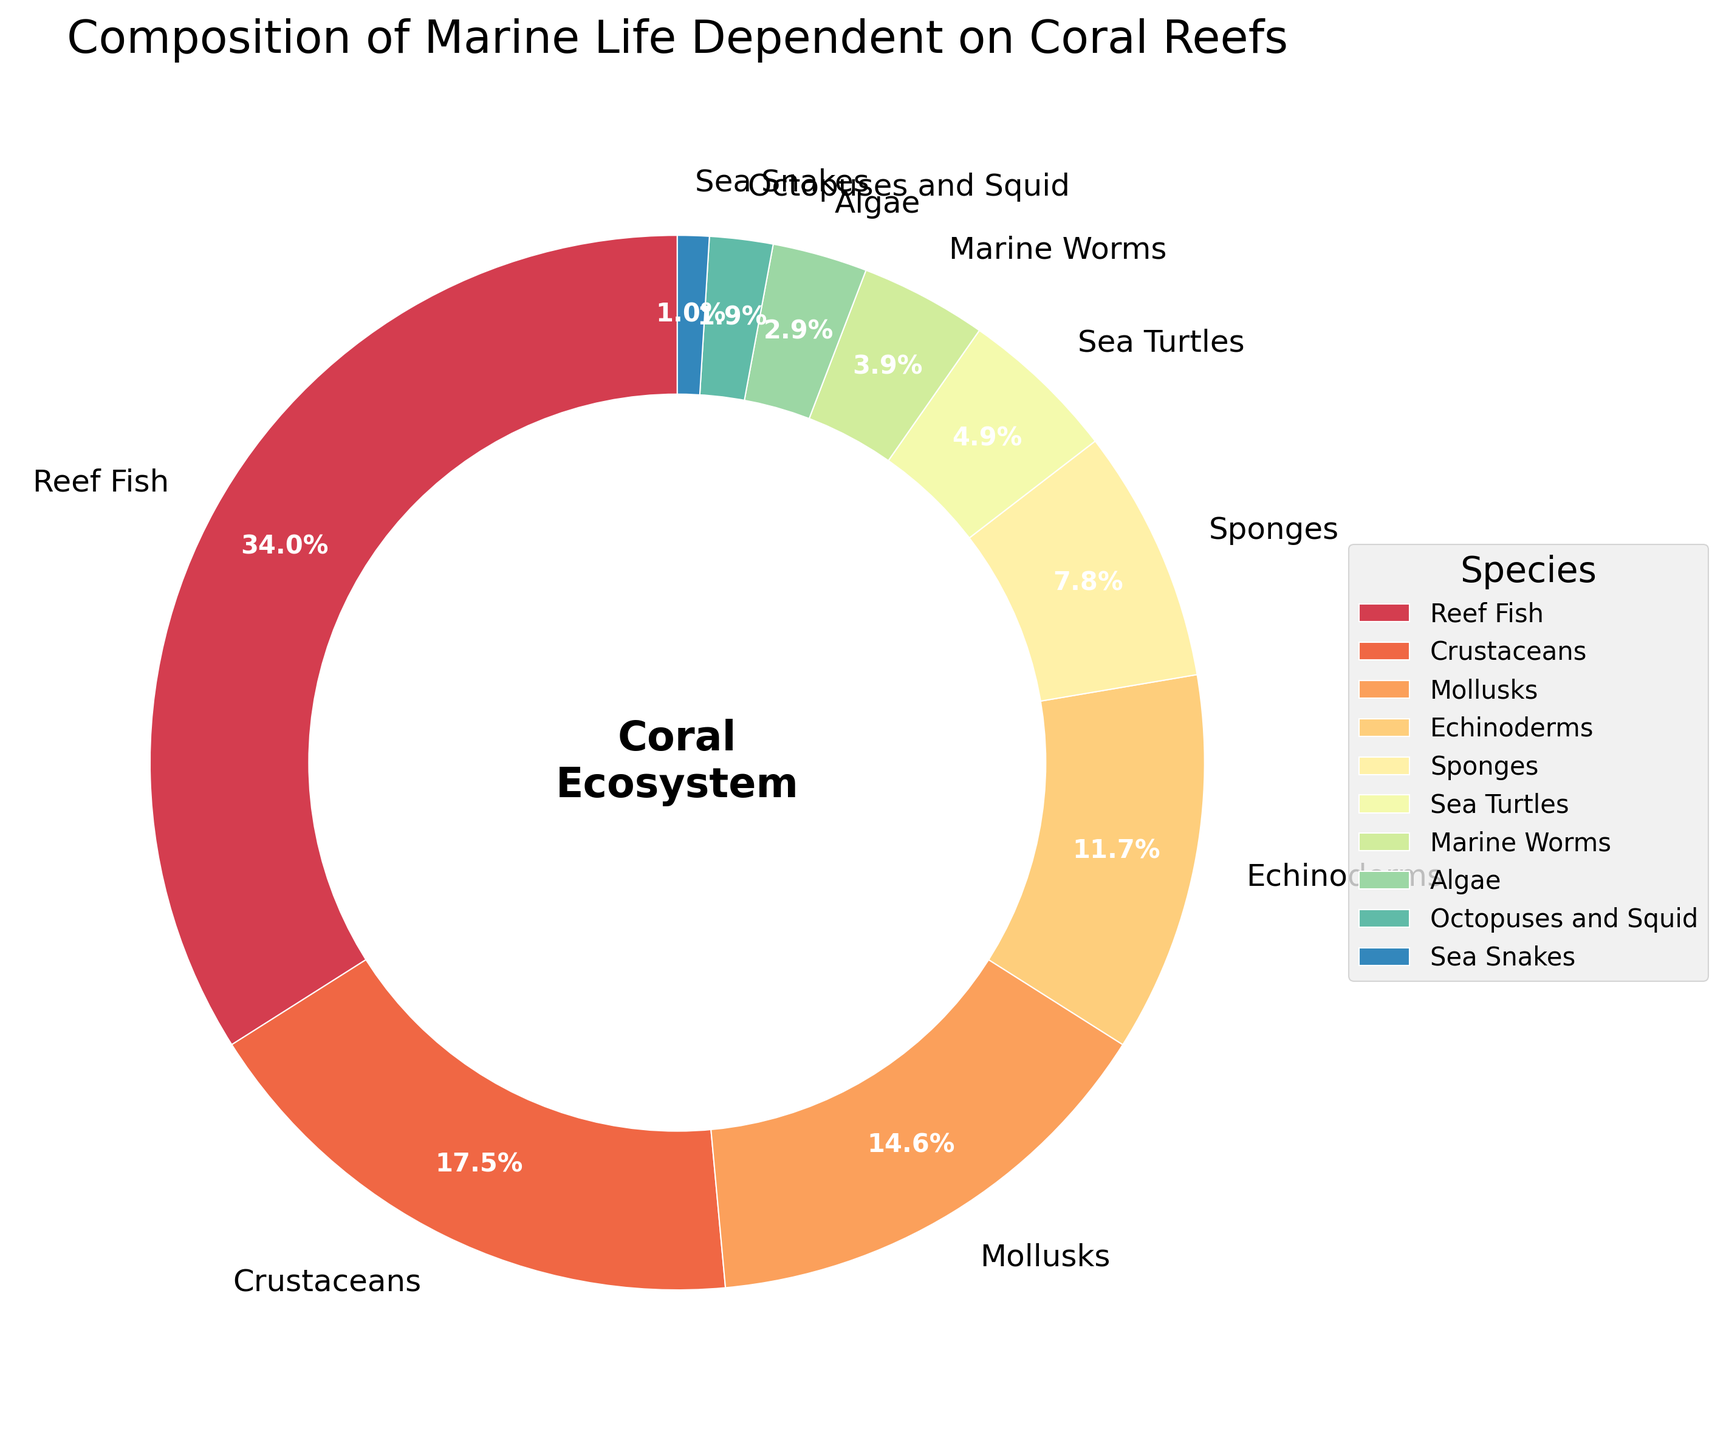What percentage of marine life on coral reefs is made up by Sea Turtles and Marine Worms combined? The figure shows that Sea Turtles make up 5% and Marine Worms make up 4% of the marine life. Adding these percentages together gives 5% + 4% = 9%.
Answer: 9% Which species has the highest percentage of marine life dependent on coral reefs? The figure shows the different percentages of each species. The highest percentage is for Reef Fish, at 35%.
Answer: Reef Fish Are Sponges or Algae more abundant on coral reefs? The figure shows that Sponges make up 8% of marine life while Algae make up 3%. Since 8% is greater than 3%, Sponges are more abundant than Algae.
Answer: Sponges What is the difference in the percentage of marine life between Echinoderms and Crustaceans? The figure shows Echinoderms make up 12% and Crustaceans make up 18%. The difference is 18% - 12% = 6%.
Answer: 6% What percentage of marine life is covered by the least abundant species groups (Octopuses and Squid, and Sea Snakes)? The figure shows that Octopuses and Squid make up 2% and Sea Snakes make up 1%. Adding these together gives 2% + 1% = 3%.
Answer: 3% Is the percentage of Crustaceans on coral reefs greater than or less than the percentage of Mollusks? The figure shows that Crustaceans make up 18% and Mollusks make up 15%. Since 18% is greater than 15%, the percentage of Crustaceans is greater.
Answer: Greater What is the average percentage of the marine life for Reef Fish, Crustaceans, and Mollusks? The figure shows Reef Fish at 35%, Crustaceans at 18%, and Mollusks at 15%. The sum of these percentages is 35% + 18% + 15% = 68%. The average is 68% / 3 = 22.67%.
Answer: 22.67% Which species are less than 5% of the marine life dependent on coral reefs? The figure shows that Sea Turtles (5%), Marine Worms (4%), Algae (3%), Octopuses and Squid (2%), and Sea Snakes (1%) are species with individual percentages less than 5%.
Answer: Marine Worms, Algae, Octopuses and Squid, Sea Snakes Is the percentage of Sponges higher or lower than the combined percentage of Sea Turtles and Marine Worms? The figure shows Sponges at 8%, and the combined percentage of Sea Turtles and Marine Worms is 5% + 4% = 9%. Since 8% is less than 9%, the percentage of Sponges is lower.
Answer: Lower 